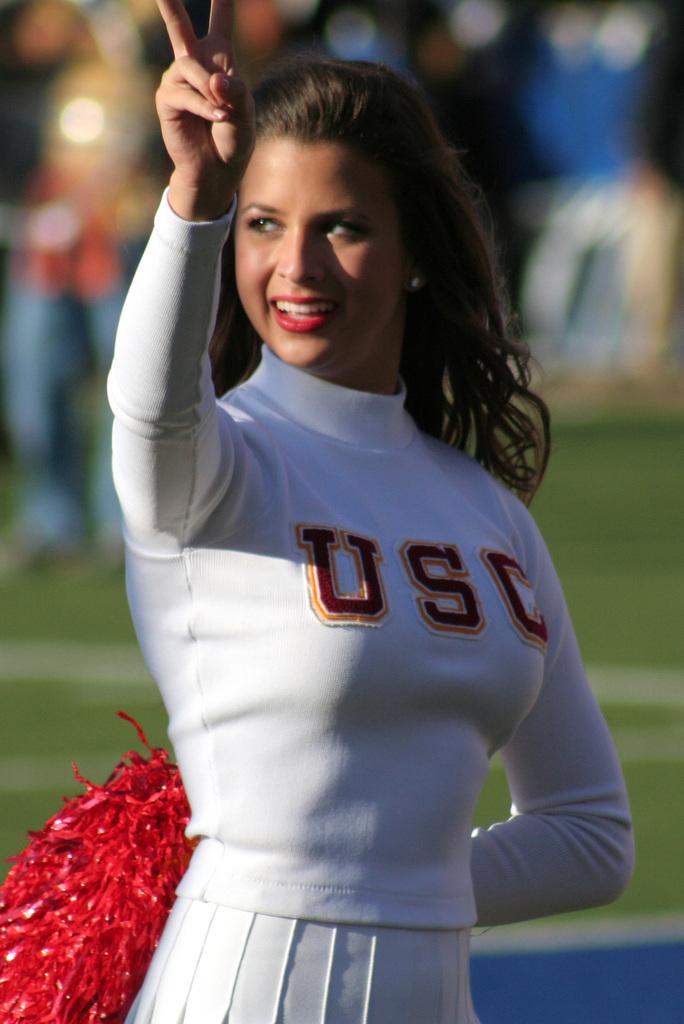What is written on her shirt?
Provide a short and direct response. Usc. 